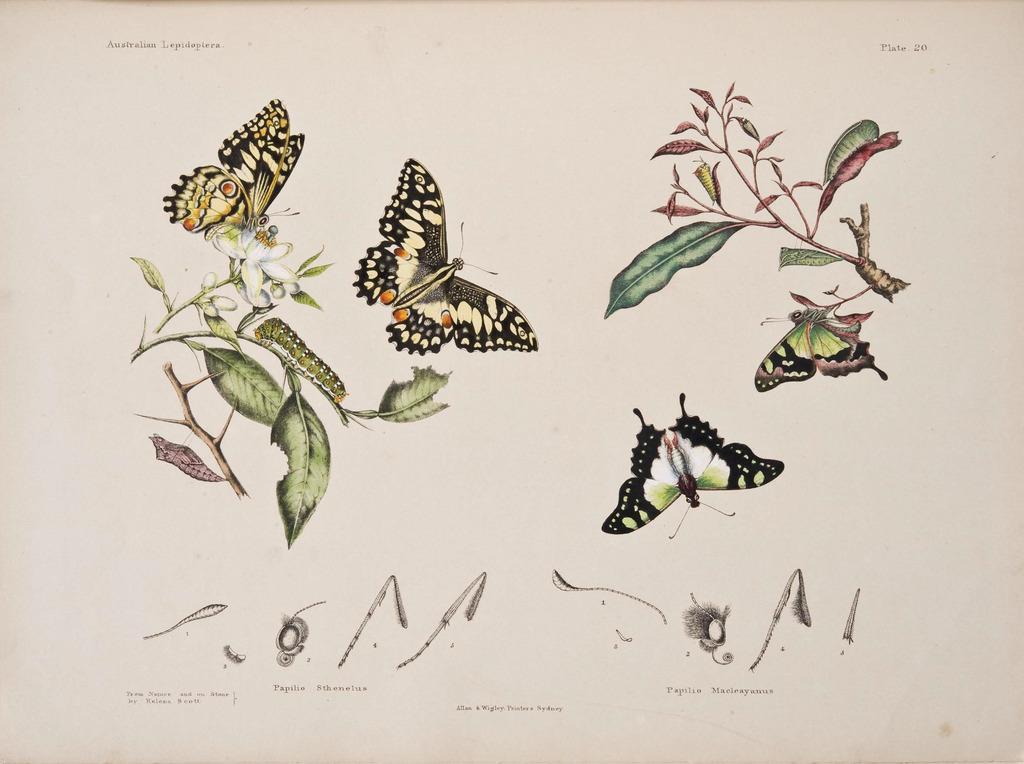Could you give a brief overview of what you see in this image? These are the pictures of butterflies and leaves of the plants. 